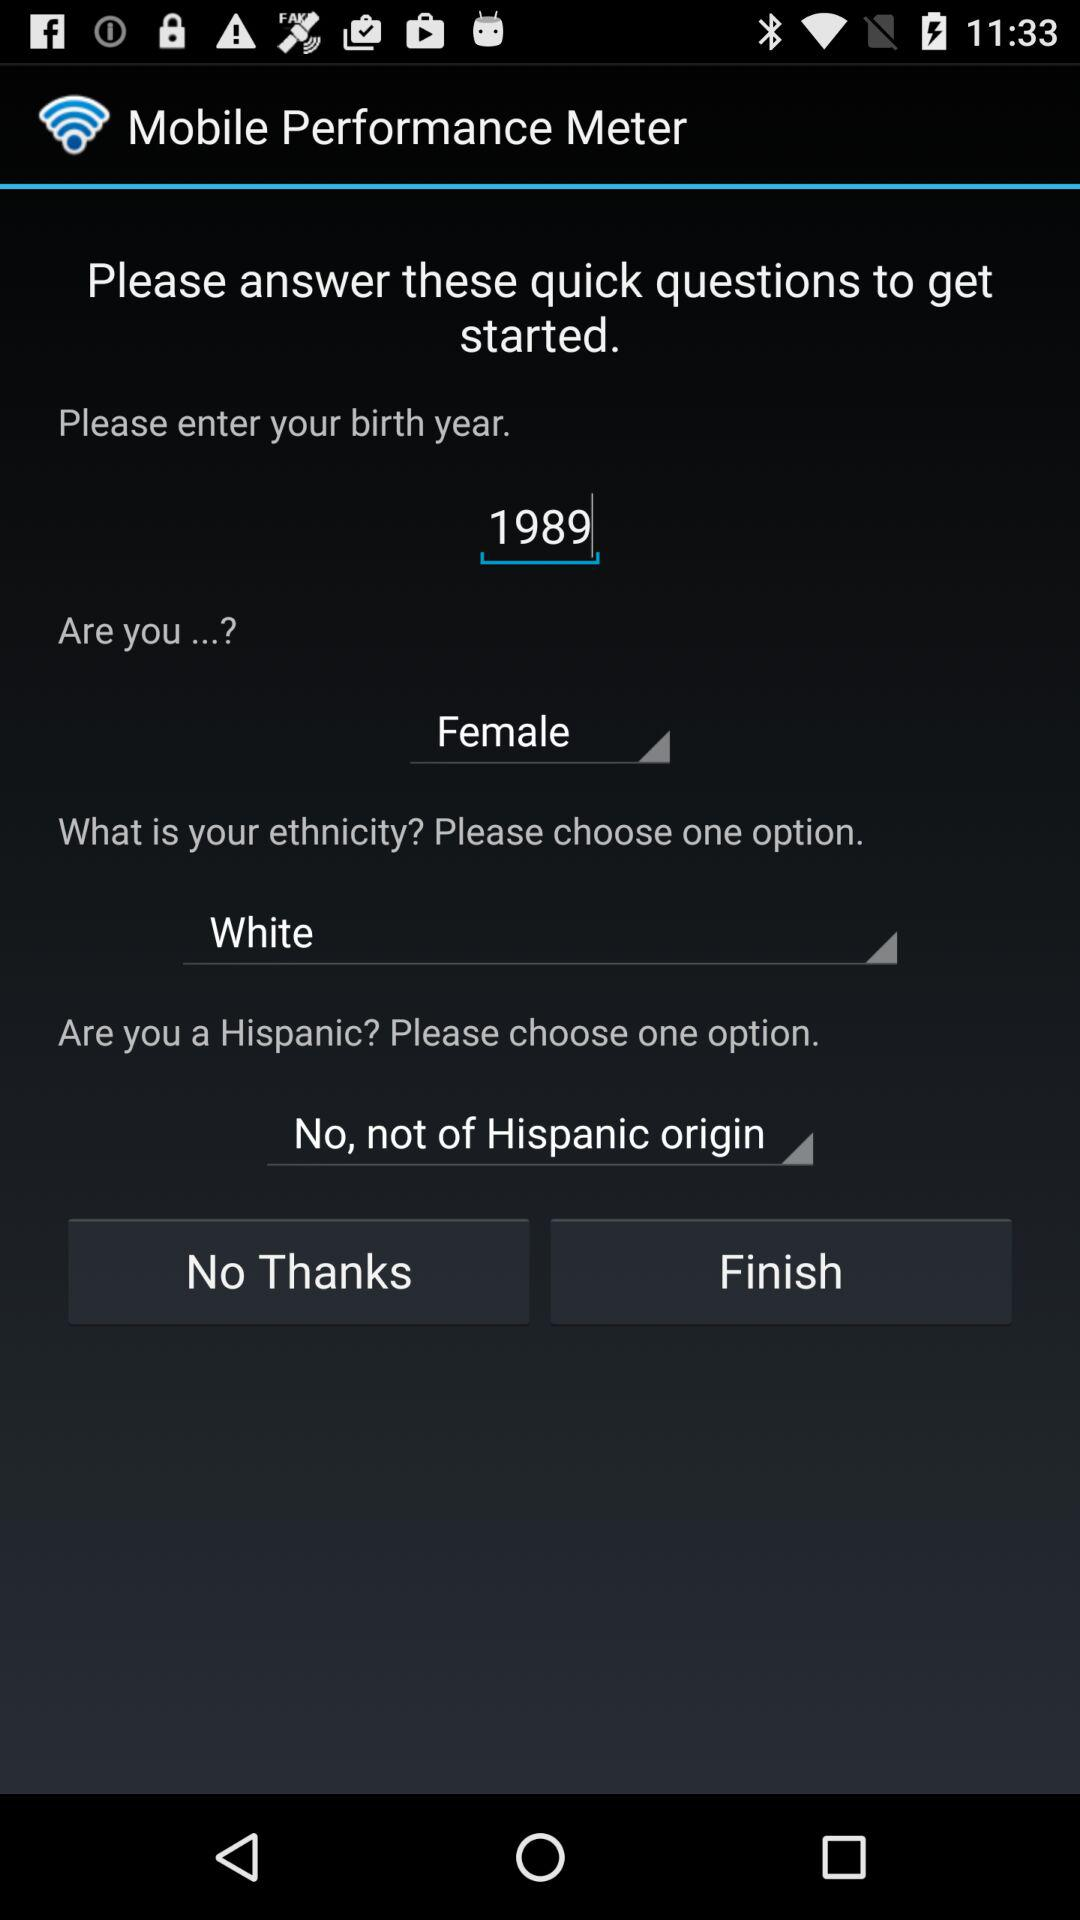What is the selected ethnicity? The selected ethnicity is "White". 